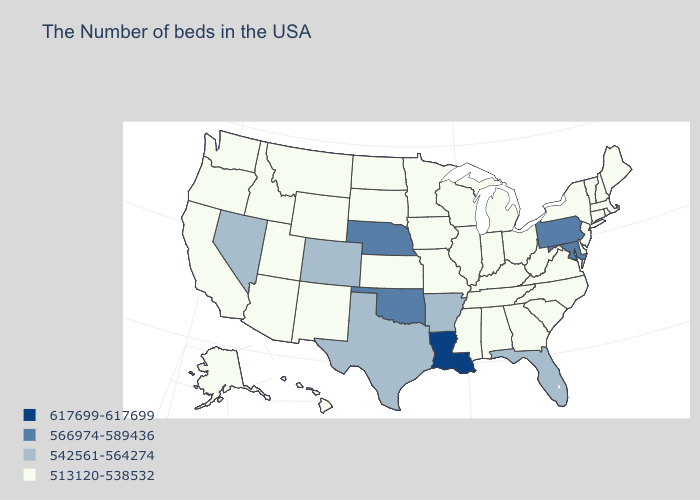Which states have the highest value in the USA?
Answer briefly. Louisiana. Does the first symbol in the legend represent the smallest category?
Short answer required. No. Does the map have missing data?
Quick response, please. No. Name the states that have a value in the range 566974-589436?
Short answer required. Maryland, Pennsylvania, Nebraska, Oklahoma. What is the value of Maryland?
Write a very short answer. 566974-589436. Does Maryland have the lowest value in the USA?
Give a very brief answer. No. Which states have the lowest value in the Northeast?
Keep it brief. Maine, Massachusetts, Rhode Island, New Hampshire, Vermont, Connecticut, New York, New Jersey. What is the highest value in the West ?
Concise answer only. 542561-564274. What is the lowest value in states that border Virginia?
Give a very brief answer. 513120-538532. Does Louisiana have the highest value in the USA?
Concise answer only. Yes. What is the value of North Carolina?
Keep it brief. 513120-538532. Does Pennsylvania have the lowest value in the Northeast?
Short answer required. No. What is the value of Wisconsin?
Short answer required. 513120-538532. Does Connecticut have a higher value than Maryland?
Quick response, please. No. 